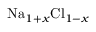Convert formula to latex. <formula><loc_0><loc_0><loc_500><loc_500>N a _ { 1 + x } C l _ { 1 - x }</formula> 